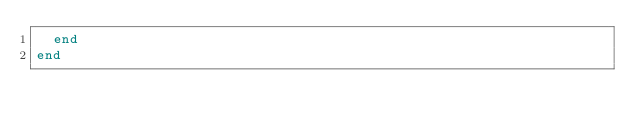<code> <loc_0><loc_0><loc_500><loc_500><_Ruby_>  end
end
</code> 